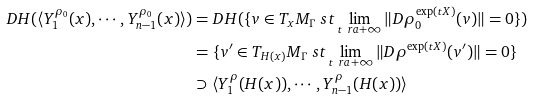Convert formula to latex. <formula><loc_0><loc_0><loc_500><loc_500>D H ( \langle Y _ { 1 } ^ { \rho _ { 0 } } ( x ) , \cdots , Y _ { n - 1 } ^ { \rho _ { 0 } } ( x ) \rangle ) & = D H ( \{ v \in T _ { x } M _ { \Gamma } \ s t \lim _ { t \ r a + \infty } \| D \rho _ { 0 } ^ { \exp ( t X ) } ( v ) \| = 0 \} ) \\ & = \{ v ^ { \prime } \in T _ { H ( x ) } M _ { \Gamma } \ s t \lim _ { t \ r a + \infty } \| D \rho ^ { \exp ( t X ) } ( v ^ { \prime } ) \| = 0 \} \\ & \supset \langle Y _ { 1 } ^ { \rho } ( H ( x ) ) , \cdots , Y _ { n - 1 } ^ { \rho } ( H ( x ) ) \rangle</formula> 